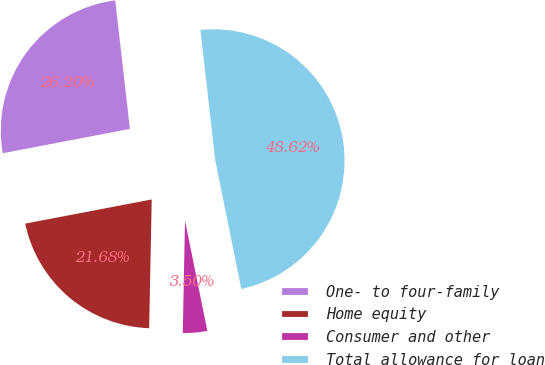<chart> <loc_0><loc_0><loc_500><loc_500><pie_chart><fcel>One- to four-family<fcel>Home equity<fcel>Consumer and other<fcel>Total allowance for loan<nl><fcel>26.2%<fcel>21.68%<fcel>3.5%<fcel>48.62%<nl></chart> 